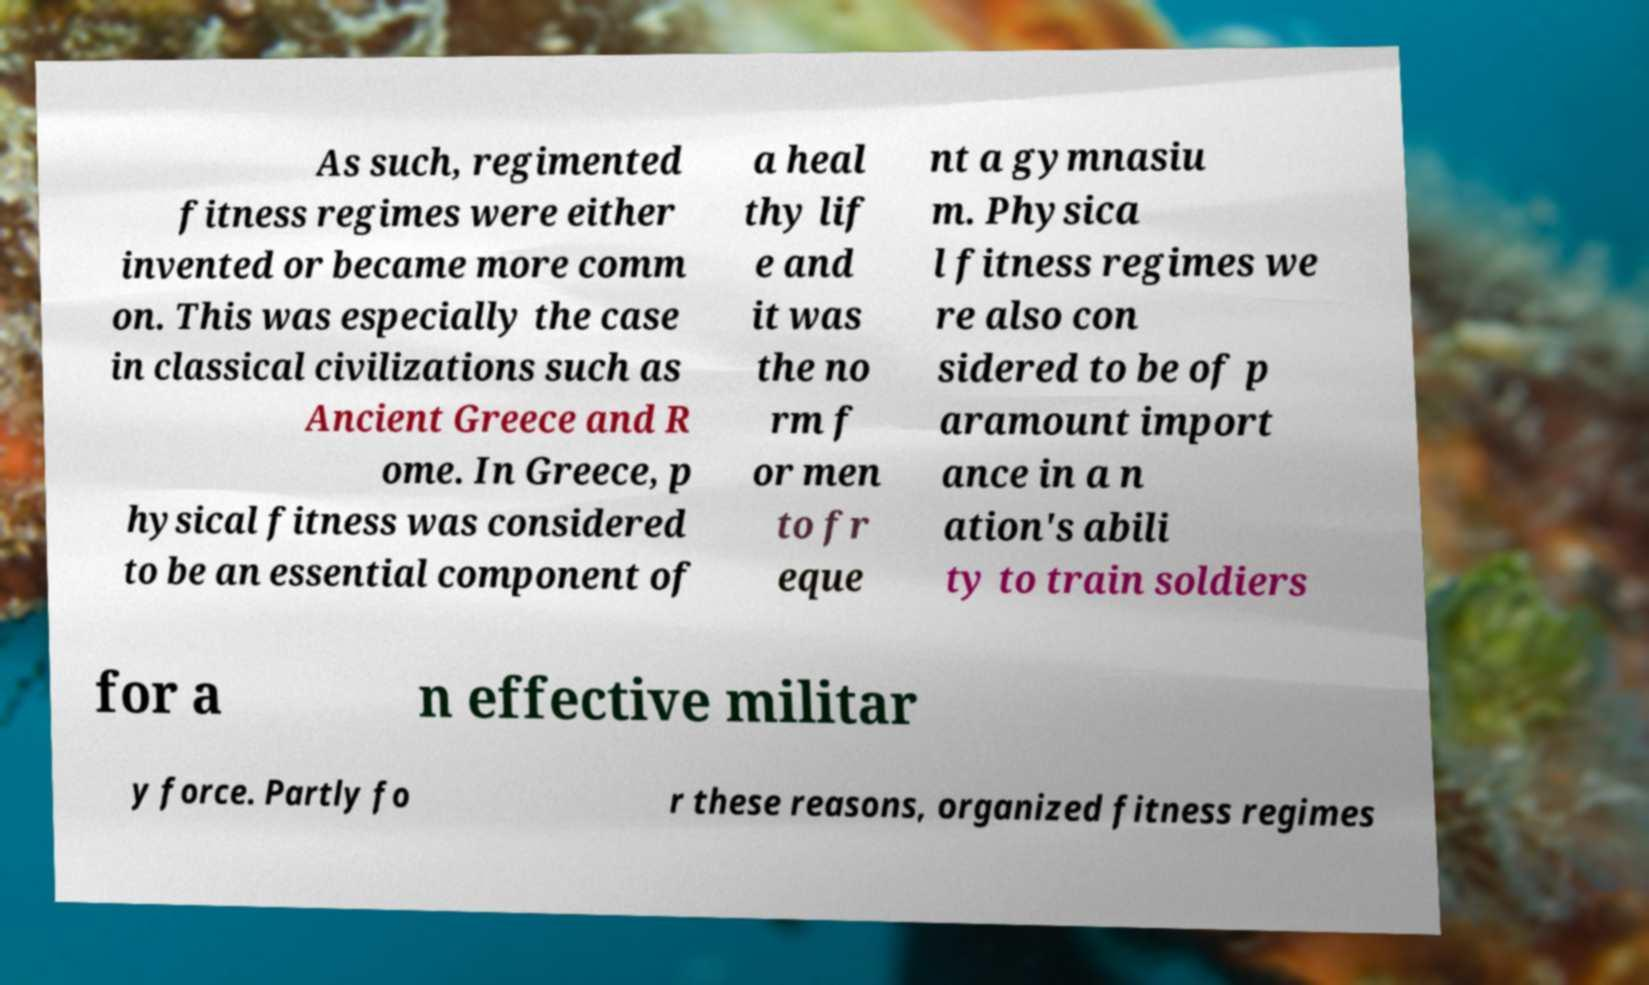Can you accurately transcribe the text from the provided image for me? As such, regimented fitness regimes were either invented or became more comm on. This was especially the case in classical civilizations such as Ancient Greece and R ome. In Greece, p hysical fitness was considered to be an essential component of a heal thy lif e and it was the no rm f or men to fr eque nt a gymnasiu m. Physica l fitness regimes we re also con sidered to be of p aramount import ance in a n ation's abili ty to train soldiers for a n effective militar y force. Partly fo r these reasons, organized fitness regimes 